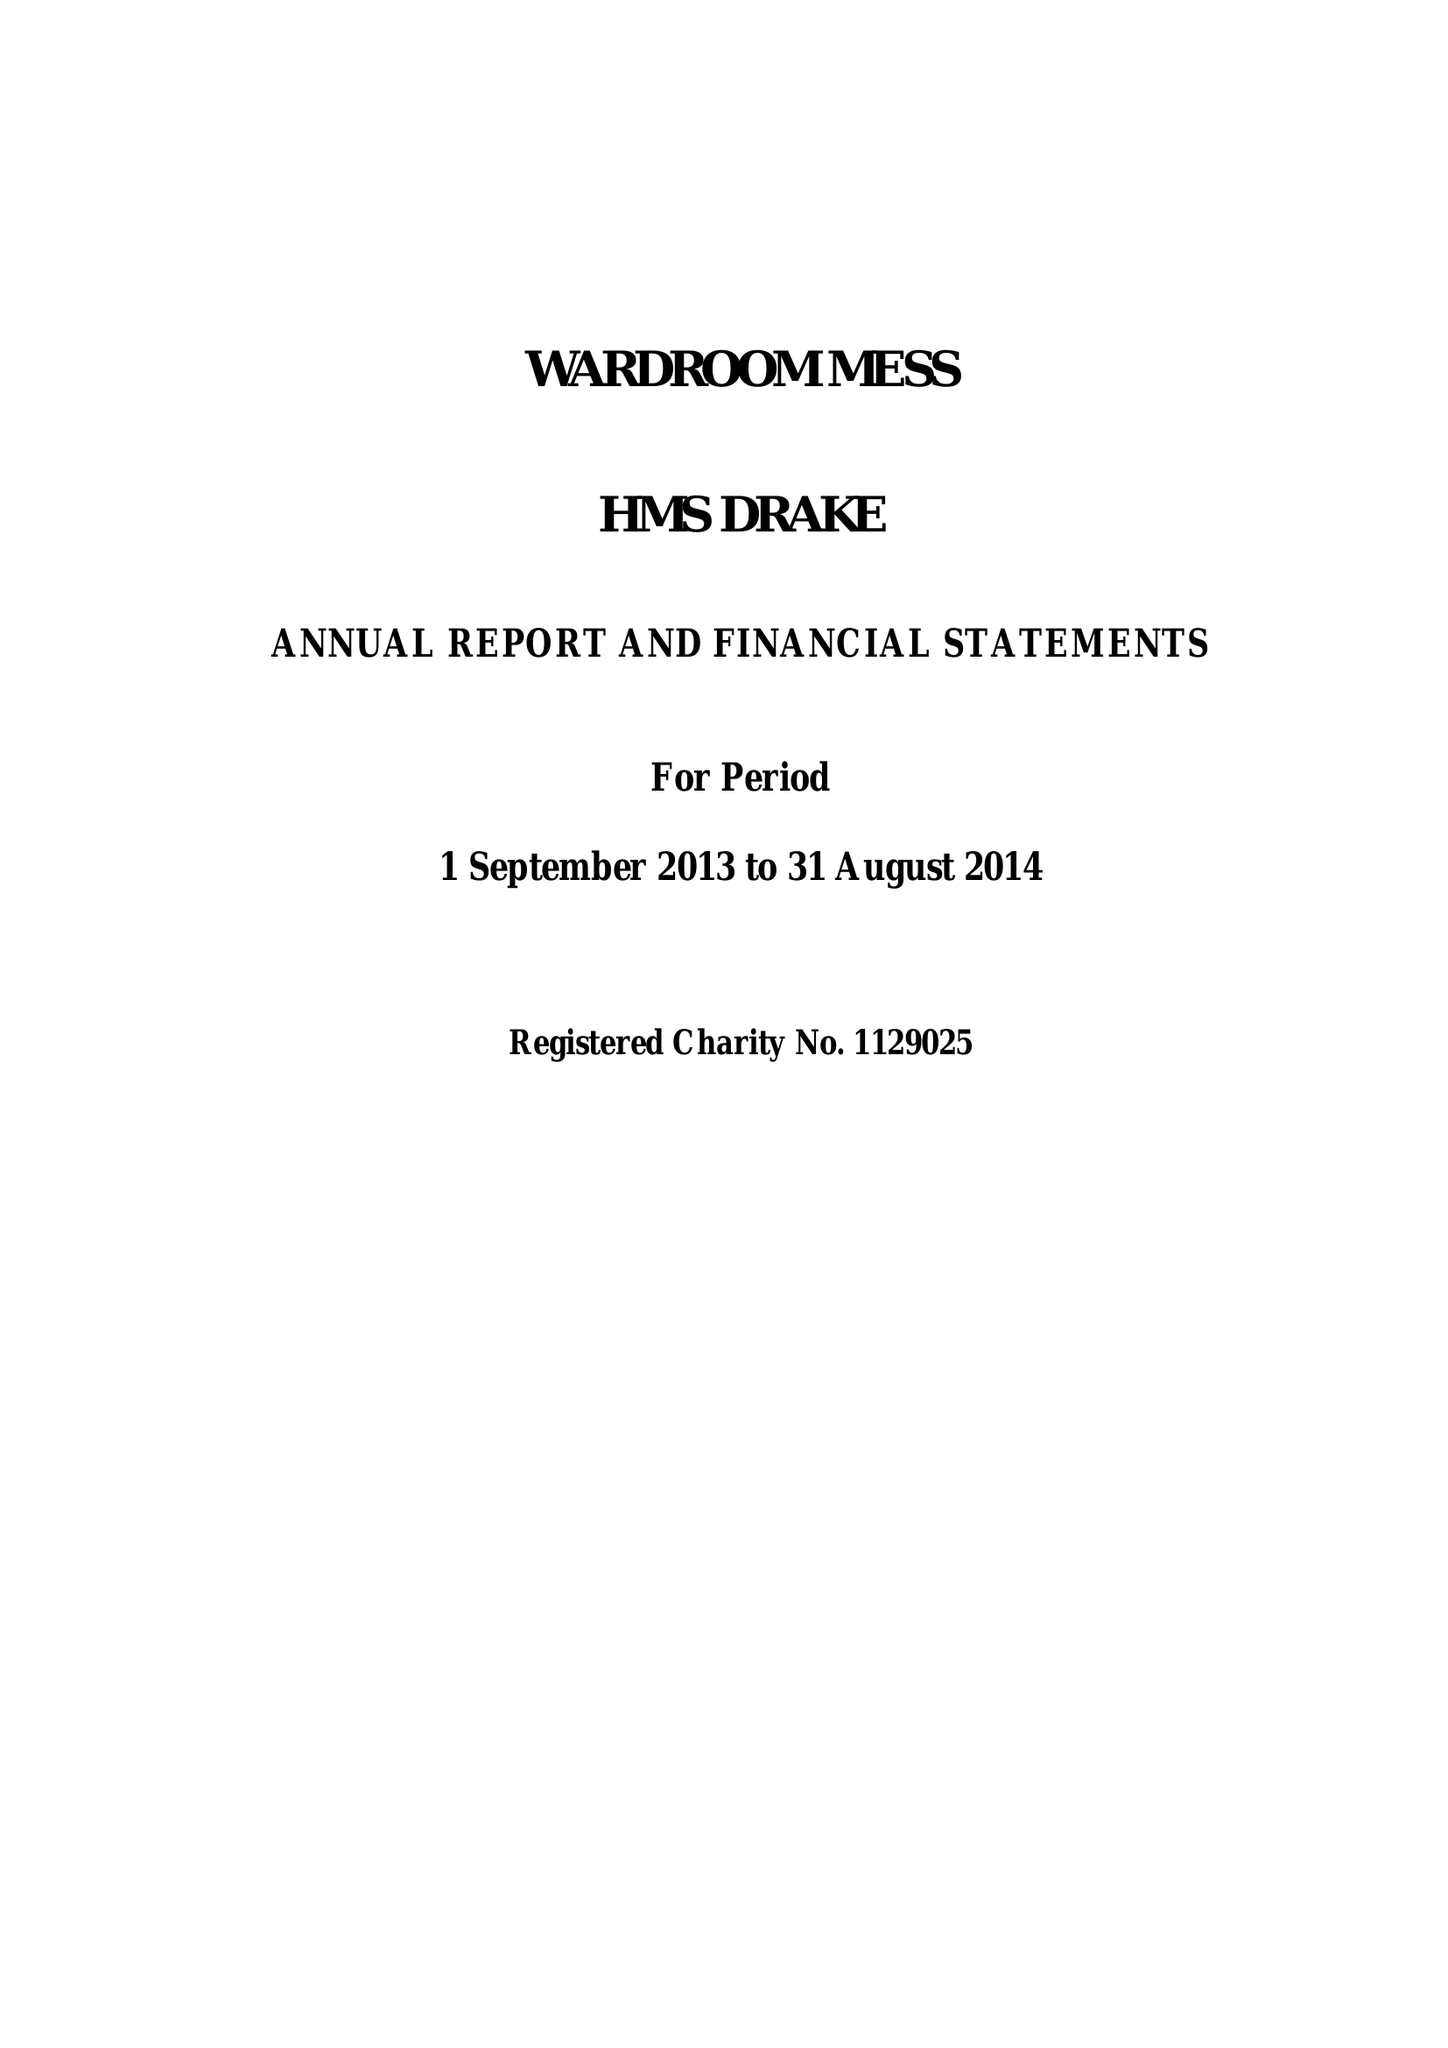What is the value for the address__postcode?
Answer the question using a single word or phrase. PL2 2BG 